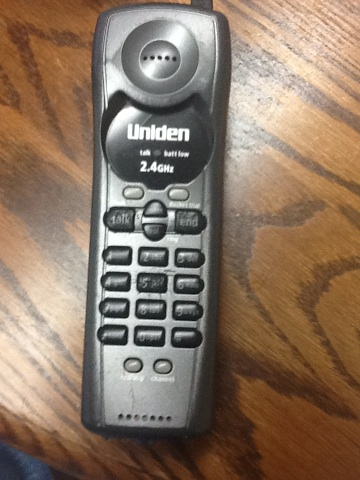Can you tell me more about the features of this device? This Uniden cordless phone likely includes features like a digital answering system, caller ID, call waiting, and a backlit LCD display. The 2.4 GHz frequency provides clearer reception and less interference from other devices. 